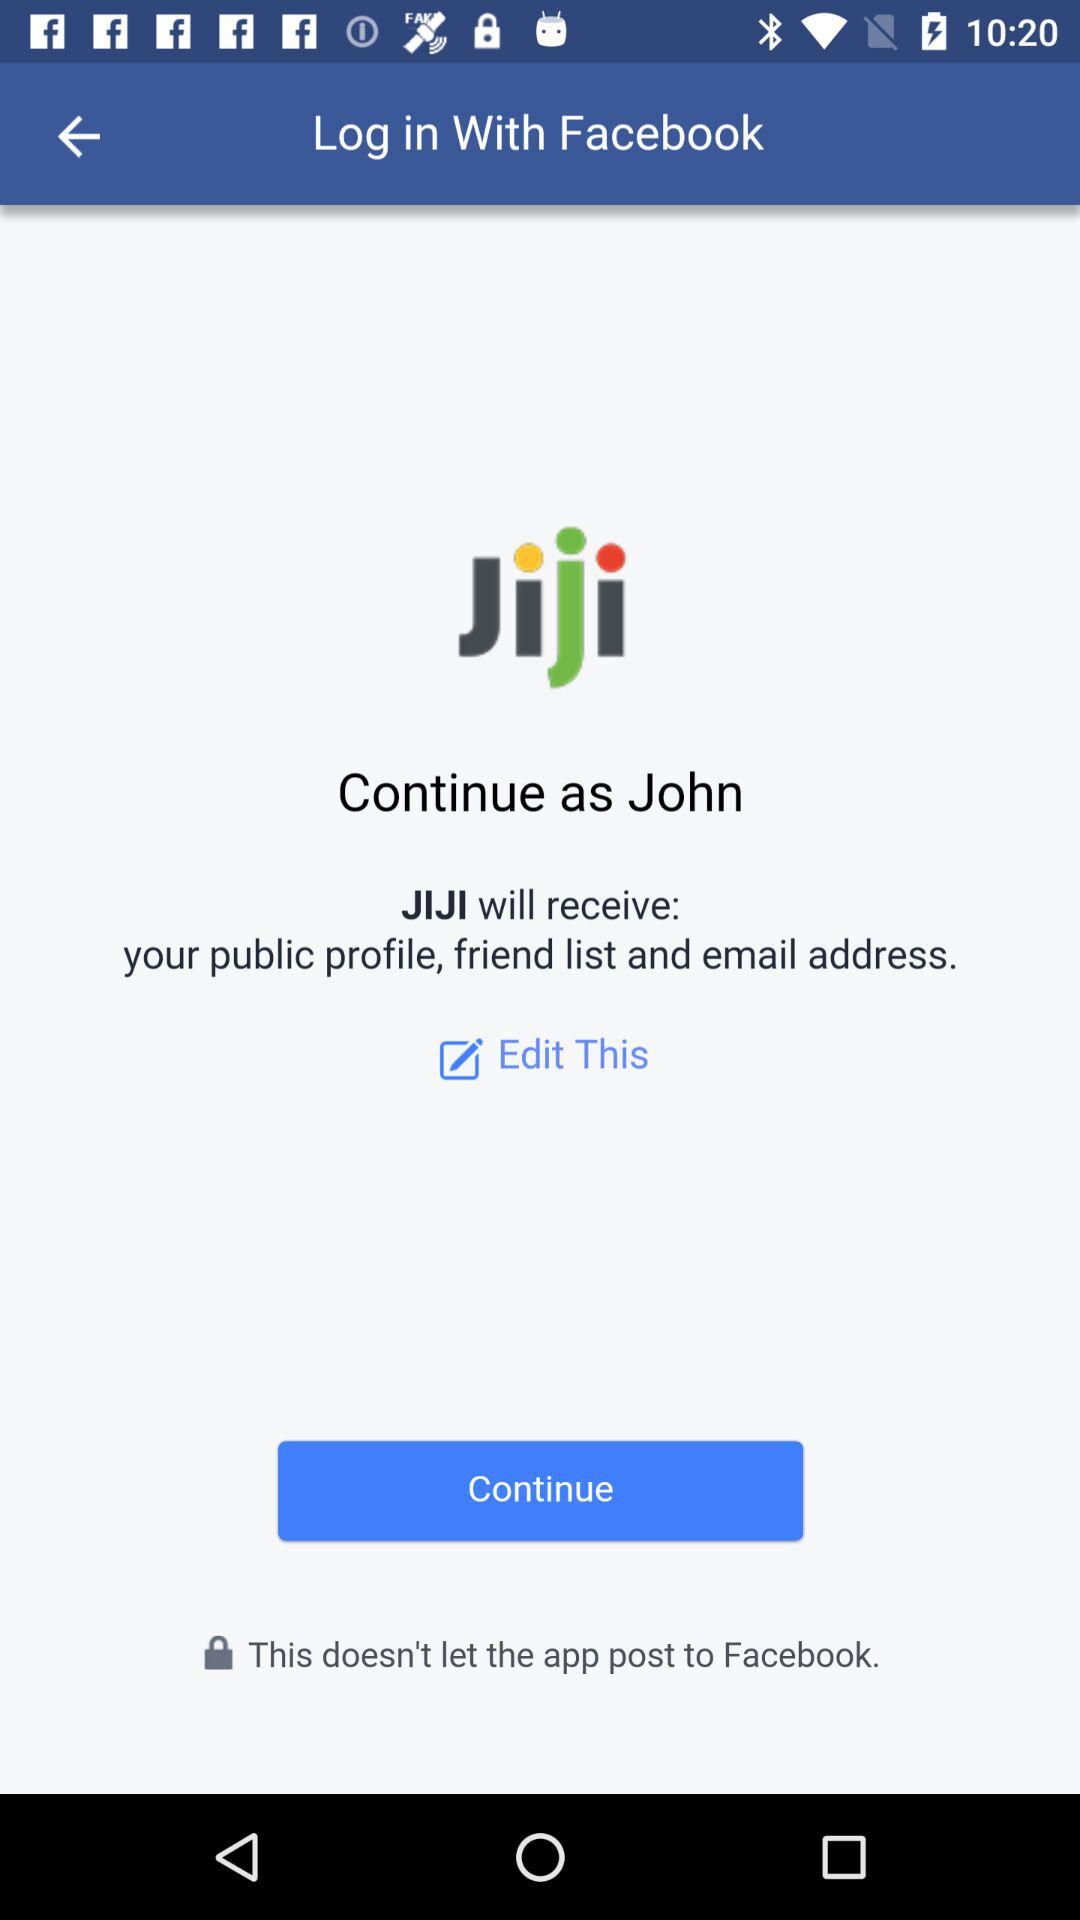What application is asking for permission? The application asking for permission is "JIJI". 